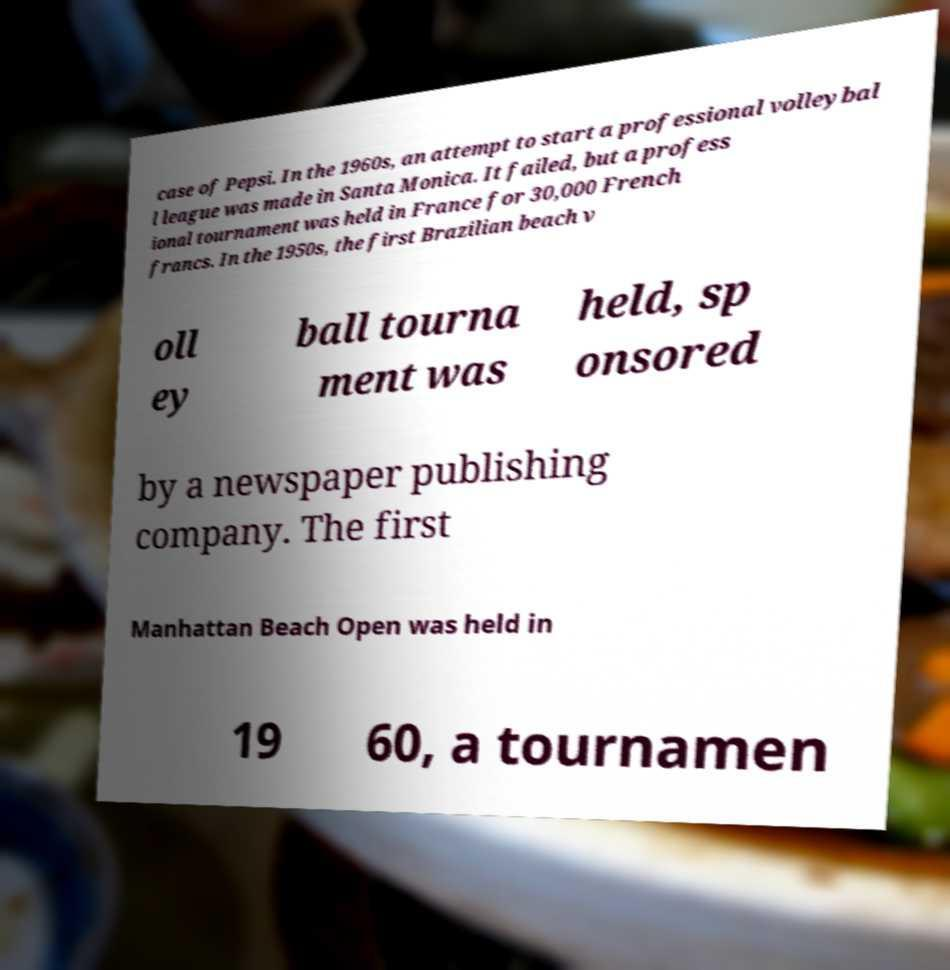I need the written content from this picture converted into text. Can you do that? case of Pepsi. In the 1960s, an attempt to start a professional volleybal l league was made in Santa Monica. It failed, but a profess ional tournament was held in France for 30,000 French francs. In the 1950s, the first Brazilian beach v oll ey ball tourna ment was held, sp onsored by a newspaper publishing company. The first Manhattan Beach Open was held in 19 60, a tournamen 